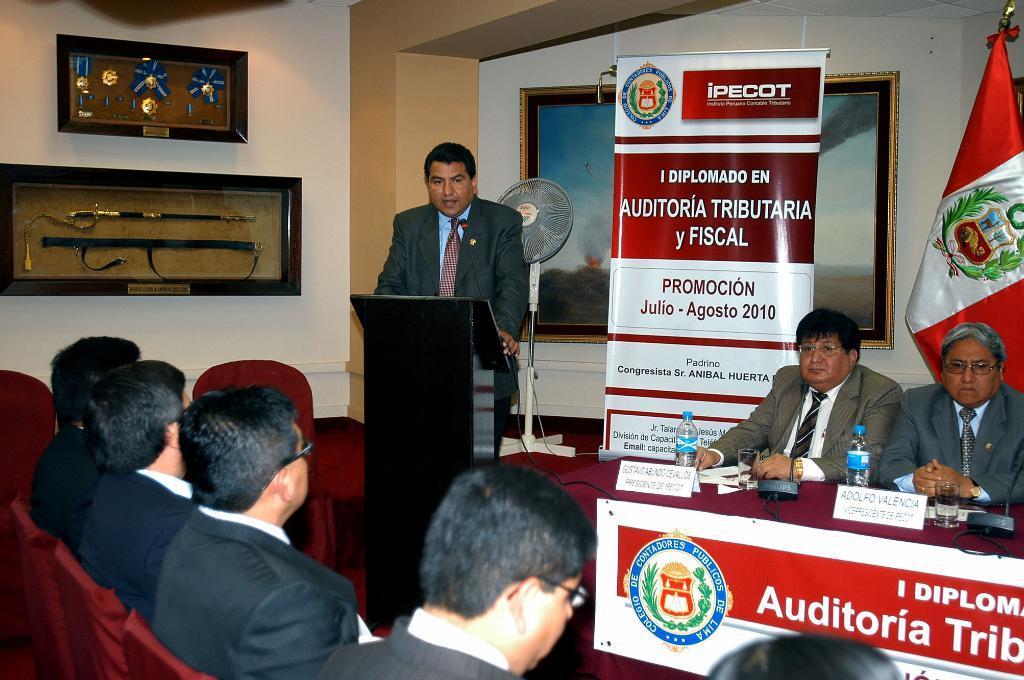Please provide a concise description of this image. In this image we can see there are people sitting on the chairs. There are bottles and boards. There is a fan, flag and hoardings. There are frames on the wall. 